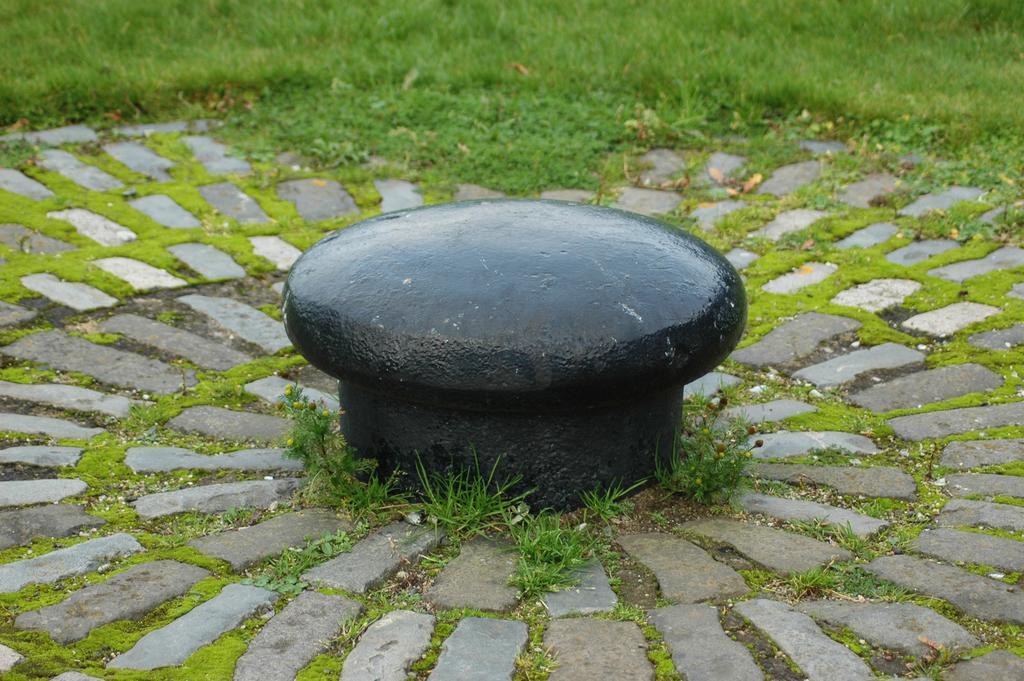Describe this image in one or two sentences. At the center of the image there is a rock structure. Around the rock structure, there is a surface of the rocks and grass. 